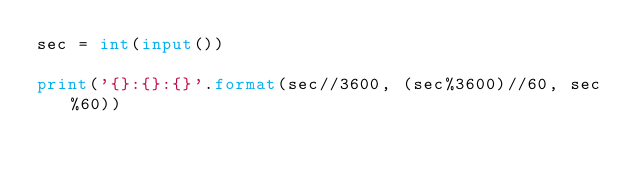<code> <loc_0><loc_0><loc_500><loc_500><_Python_>sec = int(input())

print('{}:{}:{}'.format(sec//3600, (sec%3600)//60, sec%60))
</code> 